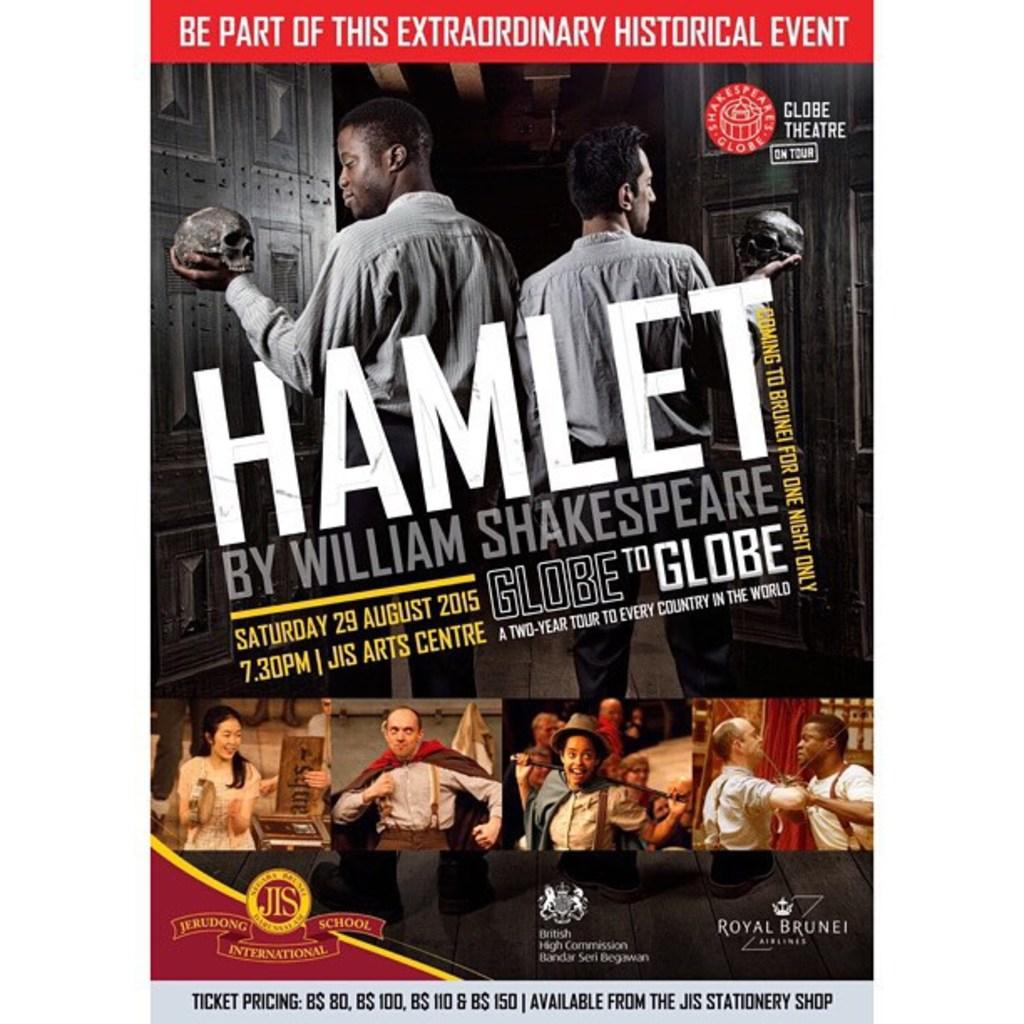Provide a one-sentence caption for the provided image. Jerudong International school is putting on a performance of Hamlet. 